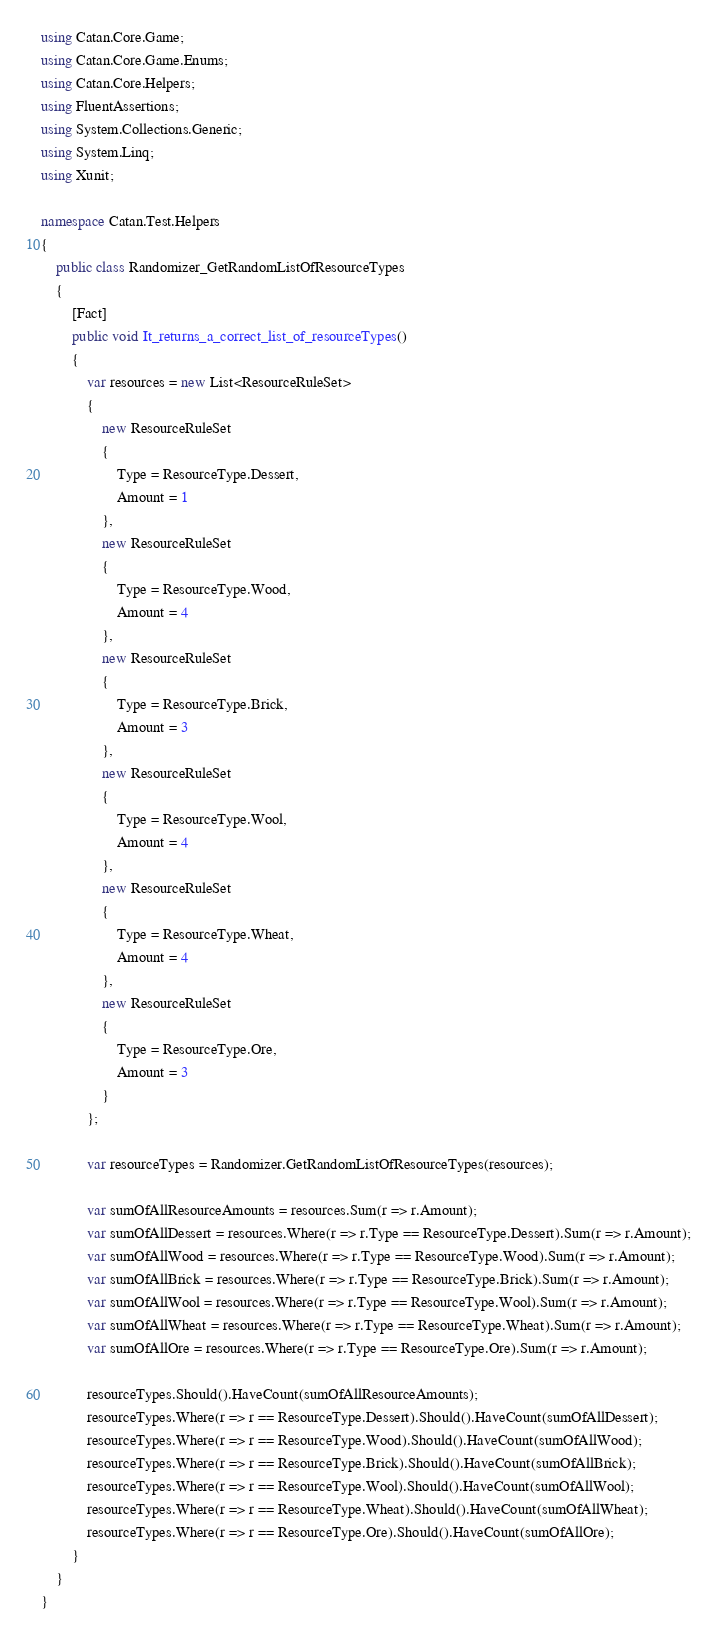<code> <loc_0><loc_0><loc_500><loc_500><_C#_>using Catan.Core.Game;
using Catan.Core.Game.Enums;
using Catan.Core.Helpers;
using FluentAssertions;
using System.Collections.Generic;
using System.Linq;
using Xunit;

namespace Catan.Test.Helpers
{
    public class Randomizer_GetRandomListOfResourceTypes
    {
        [Fact]
        public void It_returns_a_correct_list_of_resourceTypes()
        {
            var resources = new List<ResourceRuleSet>
            {
                new ResourceRuleSet
                {
                    Type = ResourceType.Dessert,
                    Amount = 1
                },
                new ResourceRuleSet
                {
                    Type = ResourceType.Wood,
                    Amount = 4
                },
                new ResourceRuleSet
                {
                    Type = ResourceType.Brick,
                    Amount = 3
                },
                new ResourceRuleSet
                {
                    Type = ResourceType.Wool,
                    Amount = 4
                },
                new ResourceRuleSet
                {
                    Type = ResourceType.Wheat,
                    Amount = 4
                },
                new ResourceRuleSet
                {
                    Type = ResourceType.Ore,
                    Amount = 3
                }
            };

            var resourceTypes = Randomizer.GetRandomListOfResourceTypes(resources);

            var sumOfAllResourceAmounts = resources.Sum(r => r.Amount);
            var sumOfAllDessert = resources.Where(r => r.Type == ResourceType.Dessert).Sum(r => r.Amount);
            var sumOfAllWood = resources.Where(r => r.Type == ResourceType.Wood).Sum(r => r.Amount);
            var sumOfAllBrick = resources.Where(r => r.Type == ResourceType.Brick).Sum(r => r.Amount);
            var sumOfAllWool = resources.Where(r => r.Type == ResourceType.Wool).Sum(r => r.Amount);
            var sumOfAllWheat = resources.Where(r => r.Type == ResourceType.Wheat).Sum(r => r.Amount);
            var sumOfAllOre = resources.Where(r => r.Type == ResourceType.Ore).Sum(r => r.Amount);

            resourceTypes.Should().HaveCount(sumOfAllResourceAmounts);
            resourceTypes.Where(r => r == ResourceType.Dessert).Should().HaveCount(sumOfAllDessert);
            resourceTypes.Where(r => r == ResourceType.Wood).Should().HaveCount(sumOfAllWood);
            resourceTypes.Where(r => r == ResourceType.Brick).Should().HaveCount(sumOfAllBrick);
            resourceTypes.Where(r => r == ResourceType.Wool).Should().HaveCount(sumOfAllWool);
            resourceTypes.Where(r => r == ResourceType.Wheat).Should().HaveCount(sumOfAllWheat);
            resourceTypes.Where(r => r == ResourceType.Ore).Should().HaveCount(sumOfAllOre);
        }
    }
}
</code> 